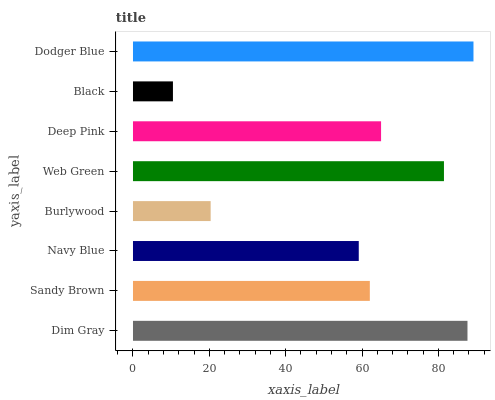Is Black the minimum?
Answer yes or no. Yes. Is Dodger Blue the maximum?
Answer yes or no. Yes. Is Sandy Brown the minimum?
Answer yes or no. No. Is Sandy Brown the maximum?
Answer yes or no. No. Is Dim Gray greater than Sandy Brown?
Answer yes or no. Yes. Is Sandy Brown less than Dim Gray?
Answer yes or no. Yes. Is Sandy Brown greater than Dim Gray?
Answer yes or no. No. Is Dim Gray less than Sandy Brown?
Answer yes or no. No. Is Deep Pink the high median?
Answer yes or no. Yes. Is Sandy Brown the low median?
Answer yes or no. Yes. Is Burlywood the high median?
Answer yes or no. No. Is Black the low median?
Answer yes or no. No. 